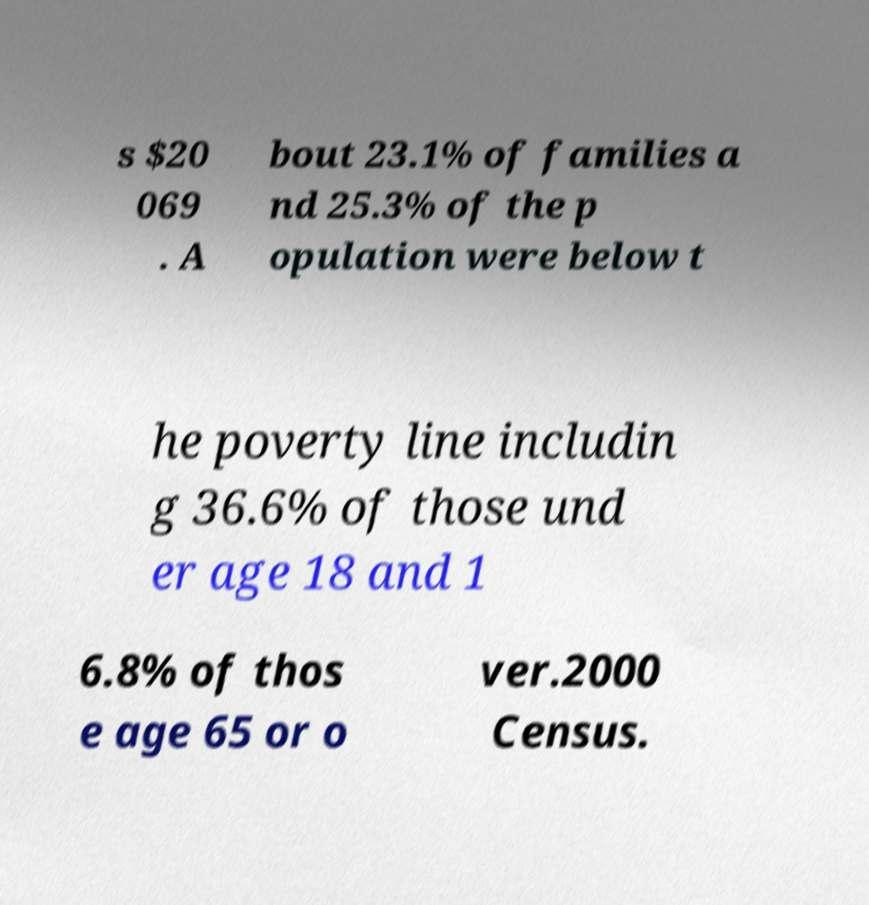Could you assist in decoding the text presented in this image and type it out clearly? s $20 069 . A bout 23.1% of families a nd 25.3% of the p opulation were below t he poverty line includin g 36.6% of those und er age 18 and 1 6.8% of thos e age 65 or o ver.2000 Census. 